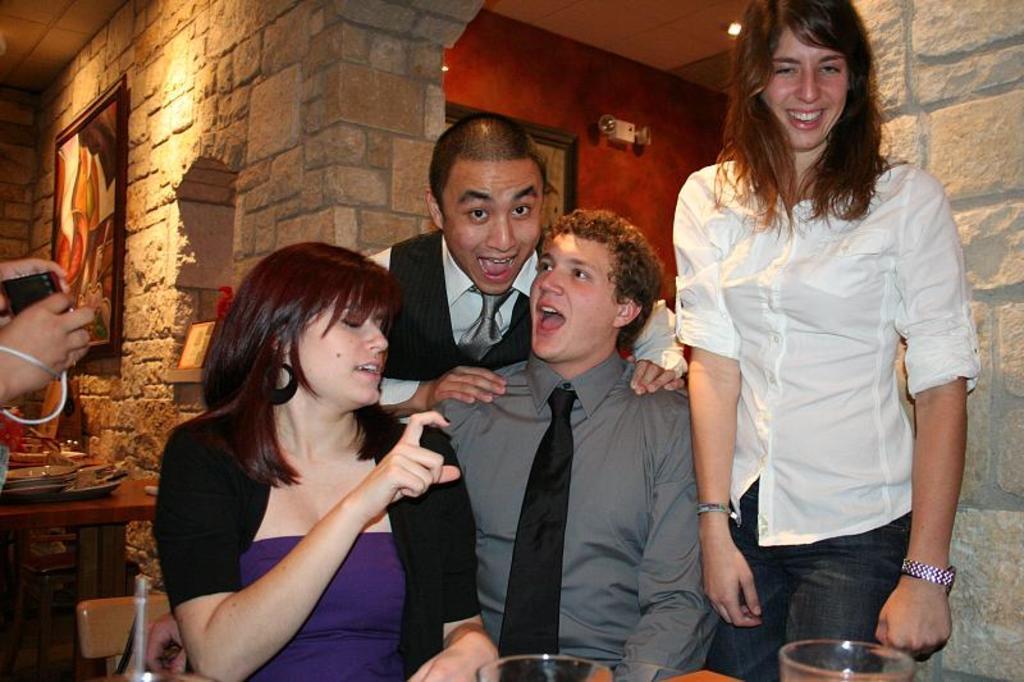Could you give a brief overview of what you see in this image? In the image in the center we can see four people,two people were sitting and two persons were standing. And they were smiling,which we can see on their faces. On the left side of the image,we can see human hands holding some object. In the bottom of the image,we can see glasses. In the background there is a wall,roof,light,photo frame,table,plates and few other objects. 